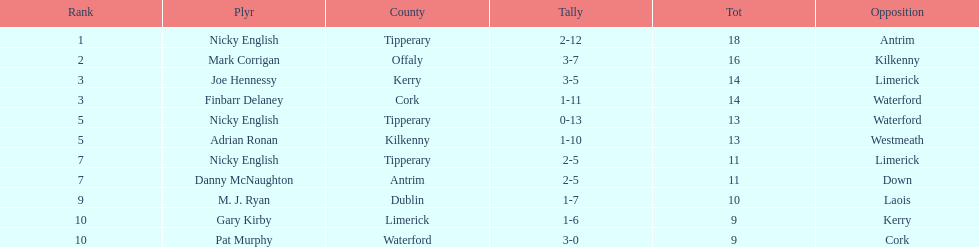What player got 10 total points in their game? M. J. Ryan. 